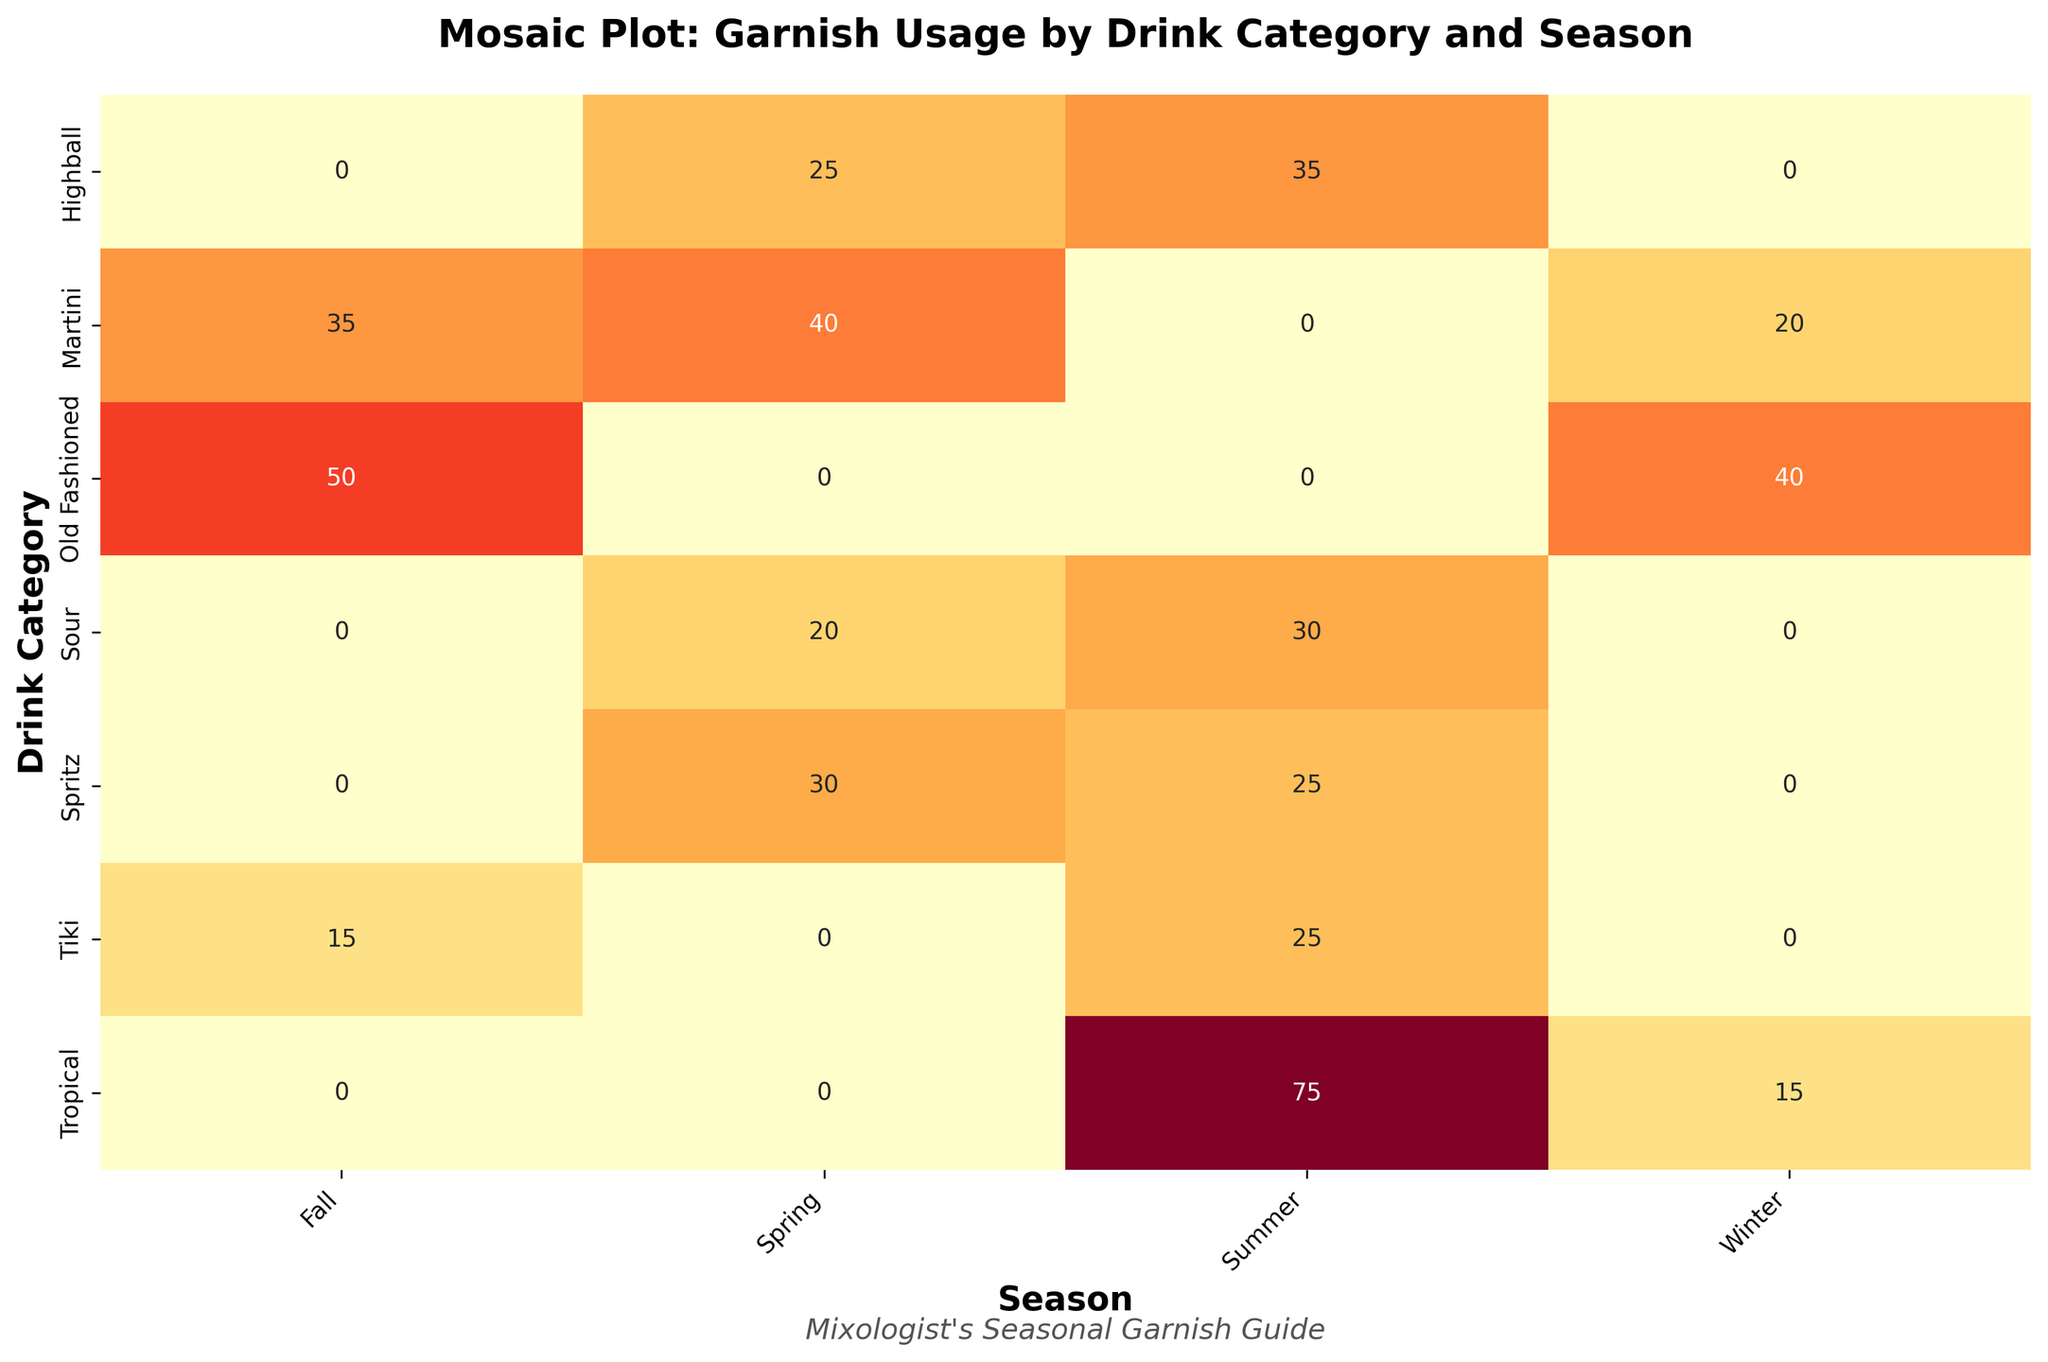What is the title of the plot? The title is written at the top of the plot and is often used to describe the purpose or subject of the plot. In this case, it states, "Mosaic Plot: Garnish Usage by Drink Category and Season."
Answer: Mosaic Plot: Garnish Usage by Drink Category and Season What is the x-axis label of the plot? The x-axis label in a Mosaic Plot often indicates the categories or variables being compared. Here, the x-axis label is "Season."
Answer: Season Which drink category has the highest garnish usage in the Fall? To find the answer, look at the "Fall" column and identify the drink category with the largest number for garnish usage. This would be Old Fashioned with a value of 50.
Answer: Old Fashioned What is the total garnish usage for Tropical drinks across all seasons? Sum the frequency of all Tropical drink garnishes given by the numbers: Summer (45 + 30) and Winter (15). This adds up to 90.
Answer: 90 Which season has the highest garnish usage for Spritz? Check the values corresponding to Spritz in each season. Spring has 30, while Summer has 25. Therefore, Spring has the highest garnish usage.
Answer: Spring How does the total garnish usage in Winter compare between Martini and Old Fashioned? In Winter, Martini has a garnish usage of 20 while Old Fashioned has a usage of 40. Comparing these, Old Fashioned has a higher usage.
Answer: Old Fashioned is higher What is the difference in garnish usage between Tropical in Summer and Martini in Spring? Calculate the total garnish usage for Tropical in Summer (45 + 30 = 75) and Martini in Spring (40). The difference is 75 - 40 = 35.
Answer: 35 Which drink category has the lowest total garnish usage across all seasons? Sum the frequencies for each drink category across all seasons and identify the one with the lowest total. Here, Tiki has 25 (Summer) + 15 (Fall) = 40, which is the lowest sum.
Answer: Tiki What is the average garnish usage for Highball drinks across Summer and Spring? For Summer, Highball has 35 and for Spring, it has 25. Average = (35 + 25) / 2 = 30.
Answer: 30 Is there any drink category that uses the same garnish across multiple seasons? Scan through each drink category to determine if a specific garnish appears in more than one season. None of the drink categories use the same garnish in different seasons.
Answer: No 